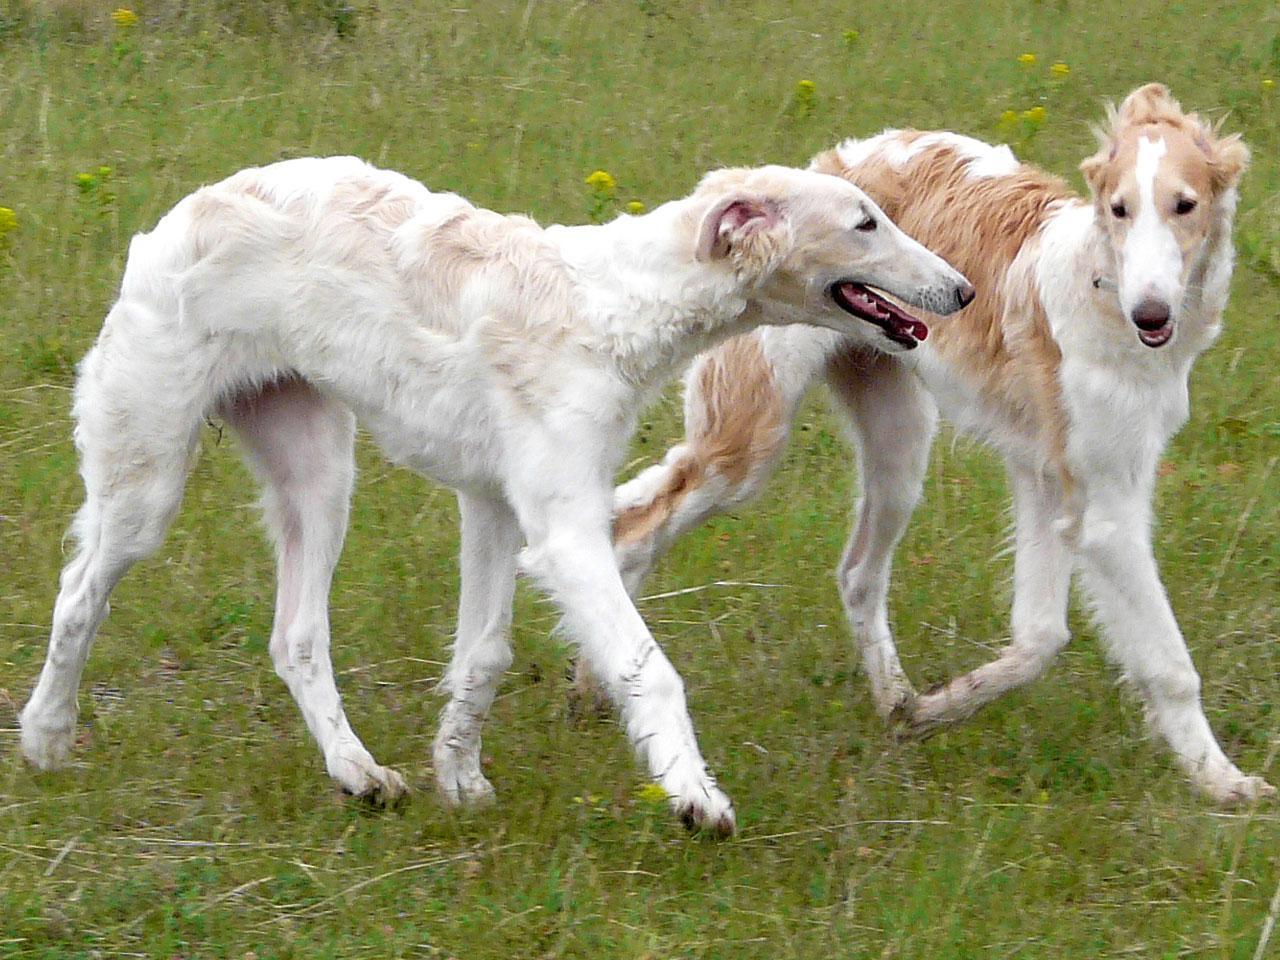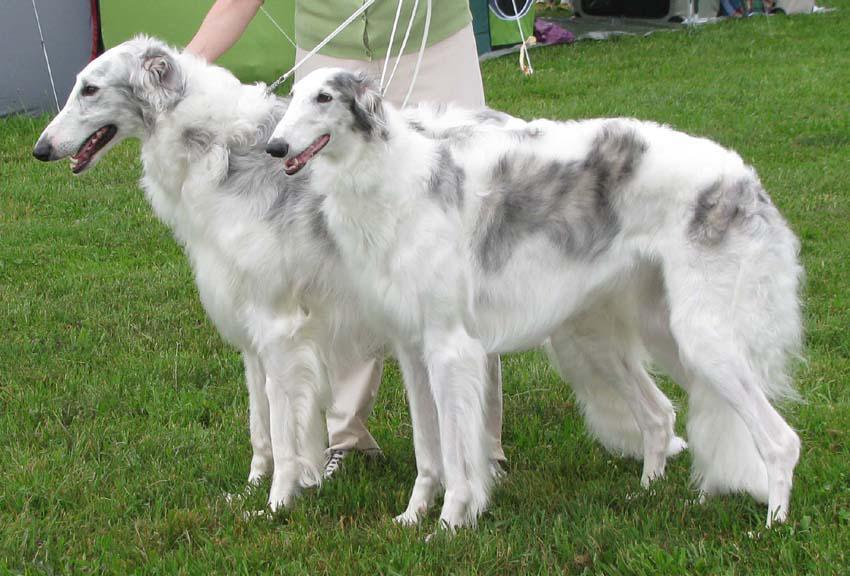The first image is the image on the left, the second image is the image on the right. For the images displayed, is the sentence "An image shows a hound with at least its two front paws fully off the ground." factually correct? Answer yes or no. No. 